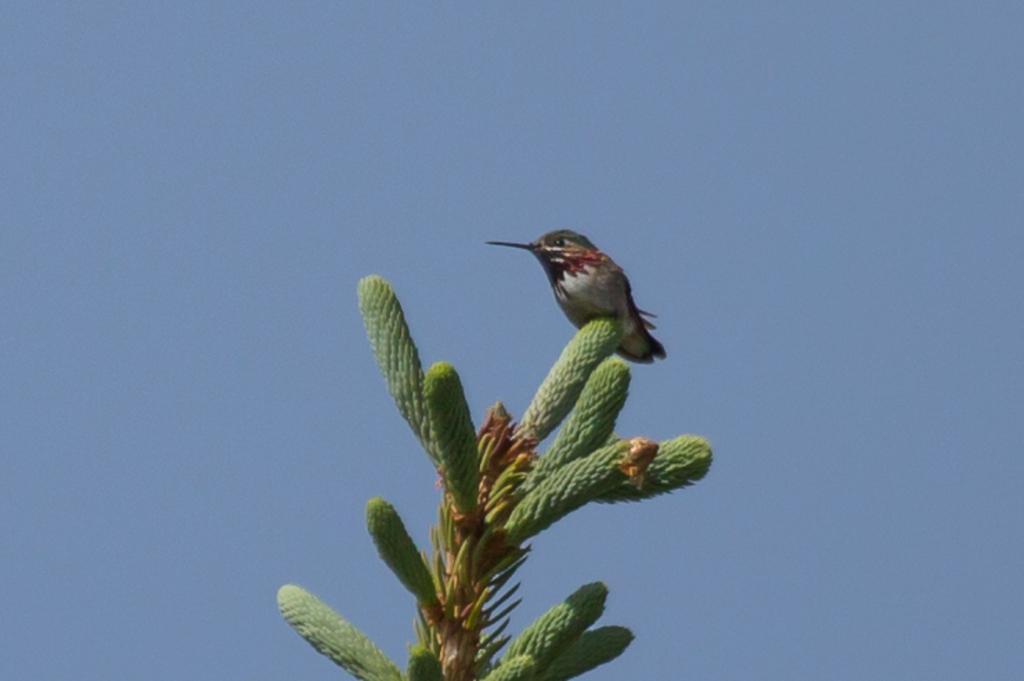Can you describe this image briefly? This image consists of a plant. On which we can see a bird. In the background, there is sky. 